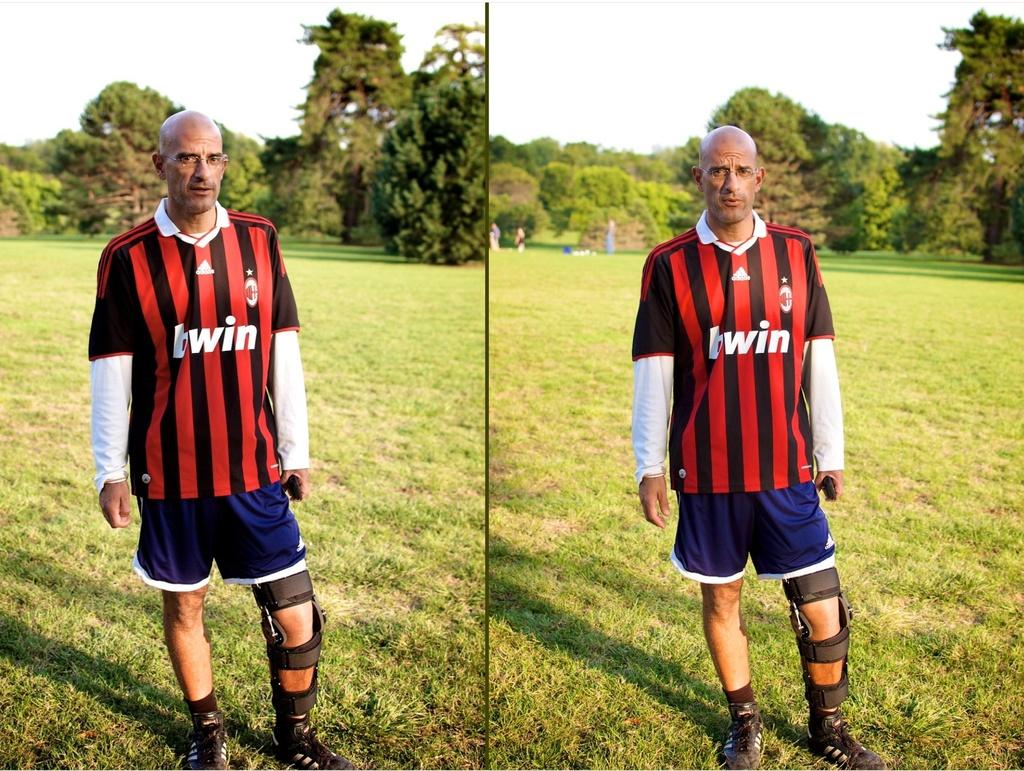What brand is the soccer shirt?
Give a very brief answer. Adidas. 